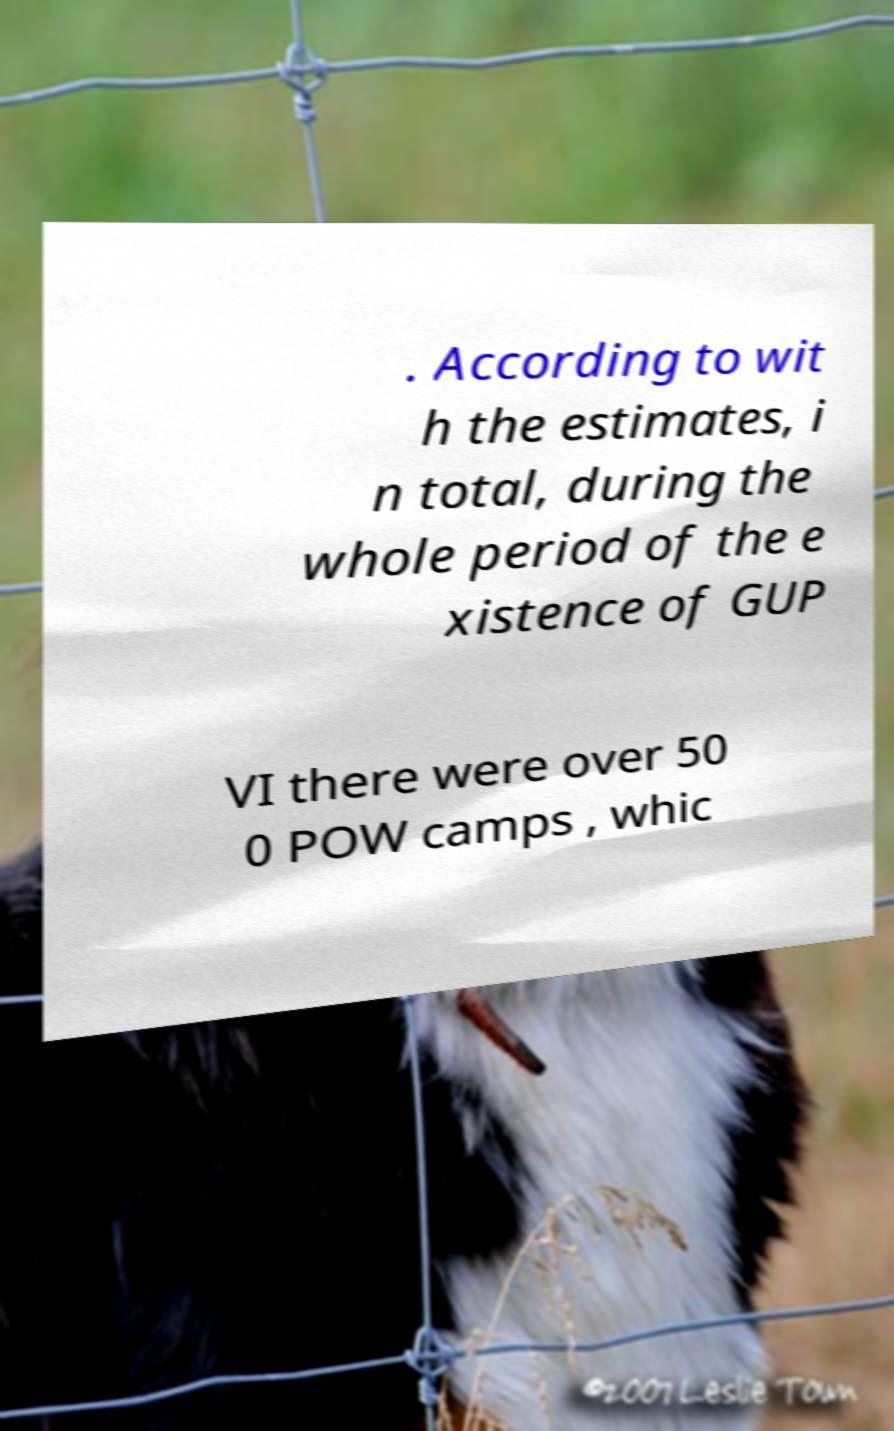There's text embedded in this image that I need extracted. Can you transcribe it verbatim? . According to wit h the estimates, i n total, during the whole period of the e xistence of GUP VI there were over 50 0 POW camps , whic 